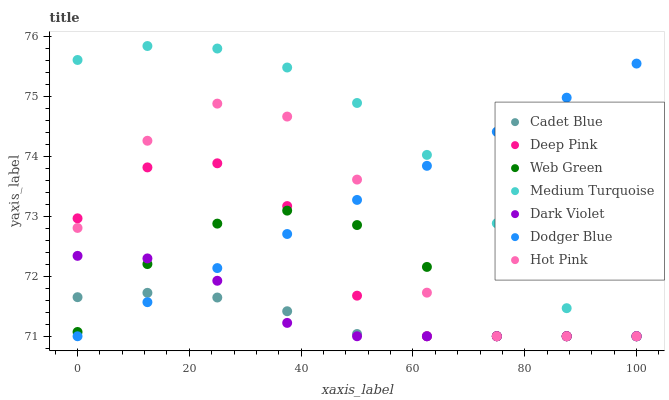Does Cadet Blue have the minimum area under the curve?
Answer yes or no. Yes. Does Medium Turquoise have the maximum area under the curve?
Answer yes or no. Yes. Does Hot Pink have the minimum area under the curve?
Answer yes or no. No. Does Hot Pink have the maximum area under the curve?
Answer yes or no. No. Is Dodger Blue the smoothest?
Answer yes or no. Yes. Is Hot Pink the roughest?
Answer yes or no. Yes. Is Dark Violet the smoothest?
Answer yes or no. No. Is Dark Violet the roughest?
Answer yes or no. No. Does Cadet Blue have the lowest value?
Answer yes or no. Yes. Does Medium Turquoise have the highest value?
Answer yes or no. Yes. Does Hot Pink have the highest value?
Answer yes or no. No. Does Hot Pink intersect Dodger Blue?
Answer yes or no. Yes. Is Hot Pink less than Dodger Blue?
Answer yes or no. No. Is Hot Pink greater than Dodger Blue?
Answer yes or no. No. 